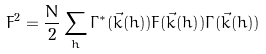<formula> <loc_0><loc_0><loc_500><loc_500>F ^ { 2 } = { \frac { N } { 2 } } \sum _ { h } \Gamma ^ { * } ( \vec { k } ( h ) ) F ( \vec { k } ( h ) ) \Gamma ( \vec { k } ( h ) )</formula> 